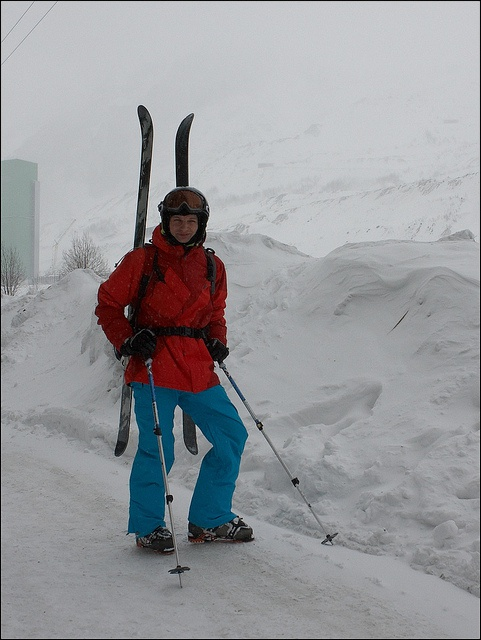Describe the objects in this image and their specific colors. I can see people in black, maroon, blue, and darkgray tones, backpack in black, maroon, gray, and darkgray tones, and skis in black, gray, purple, and darkgray tones in this image. 